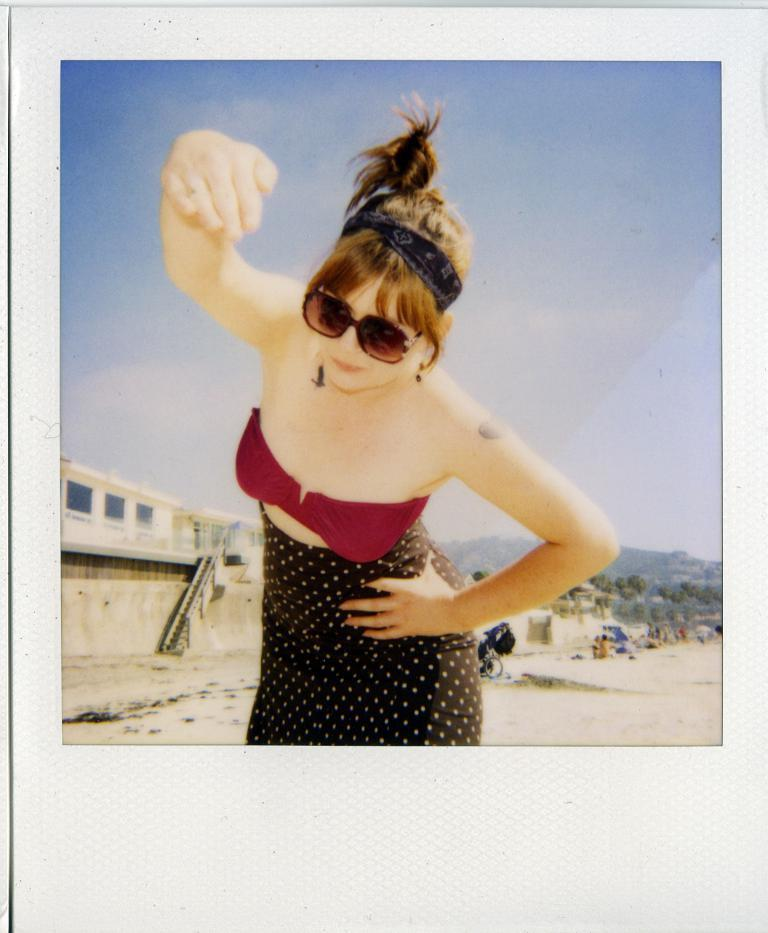Who is present in the image? There is a woman in the image. What is the woman wearing on her face? The woman is wearing goggles. What type of structure can be seen in the image? There is a building in the image. What natural elements are present in the image? There are trees and a mountain in the image. What else can be seen in the image besides the woman and the natural elements? There are objects in the image. What is visible in the background of the image? The sky is visible in the background of the image. What month is depicted in the image? There is no specific month depicted in the image; it is a general scene with no seasonal or time-related indicators. 